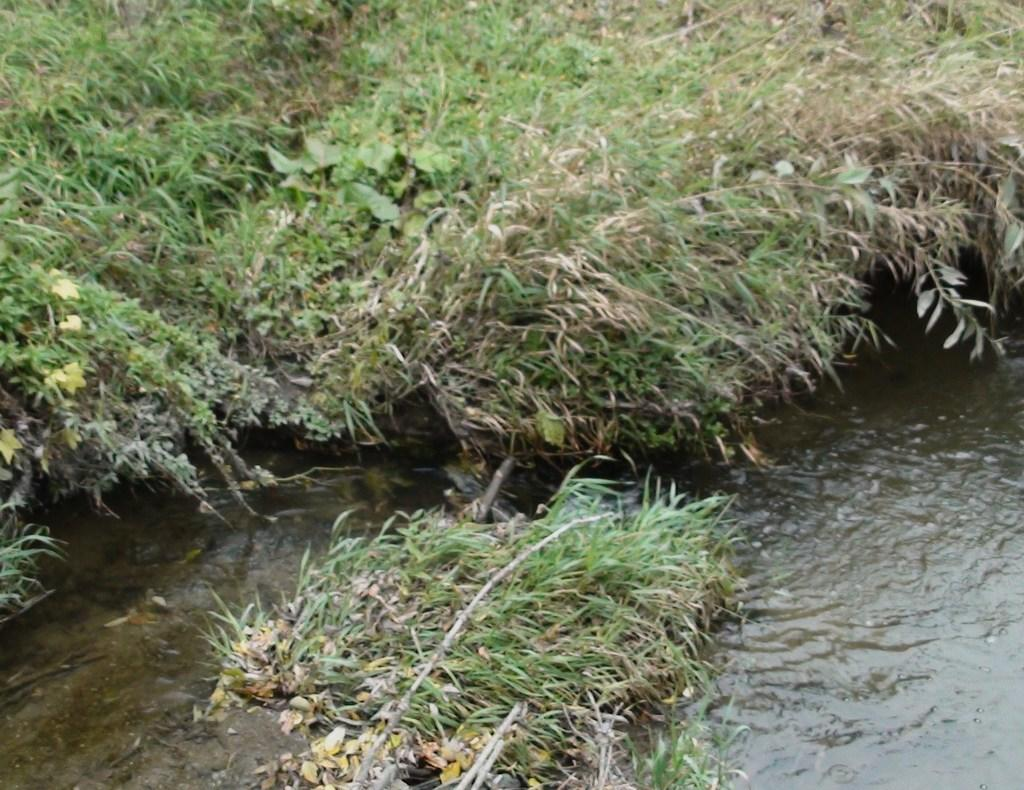What type of natural feature can be seen in the image? There is a river in the image. What type of vegetation is present in the image? There is grass in the image. What type of board is used to prevent the river from flooding in the image? There is no board present in the image to prevent flooding; the image only shows a river and grass. 